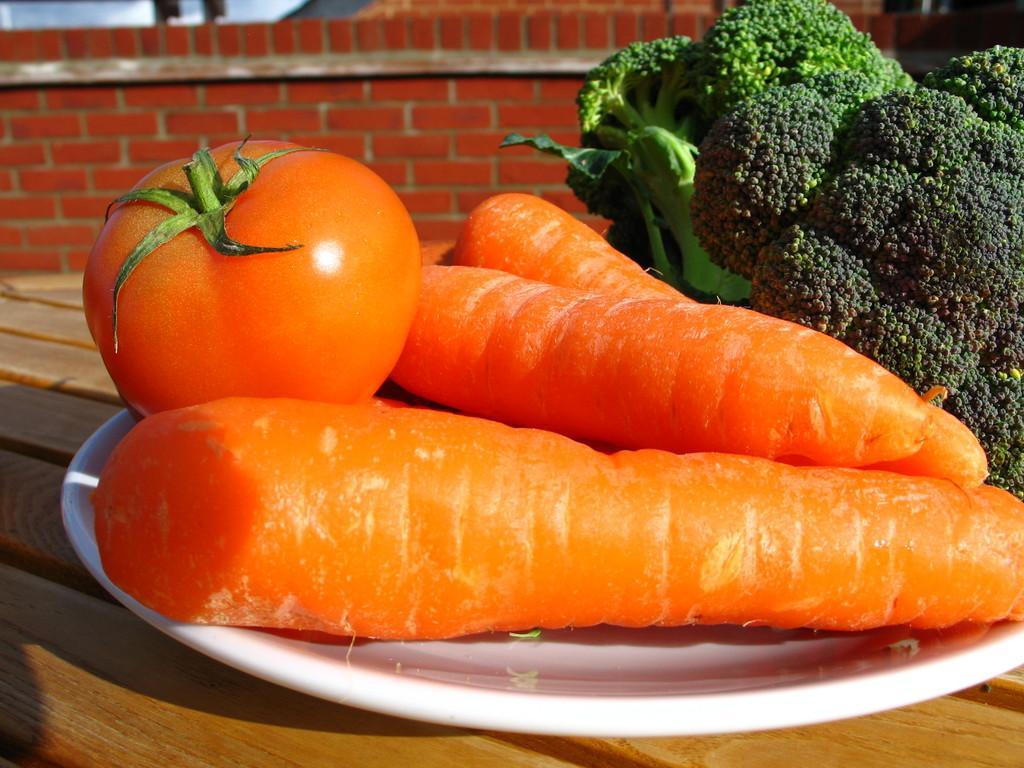In one or two sentences, can you explain what this image depicts? In this image we can see some vegetables containing tomatoes, carrots and broccoli in a plate which is placed on the table. On the backside we can see a wall. 